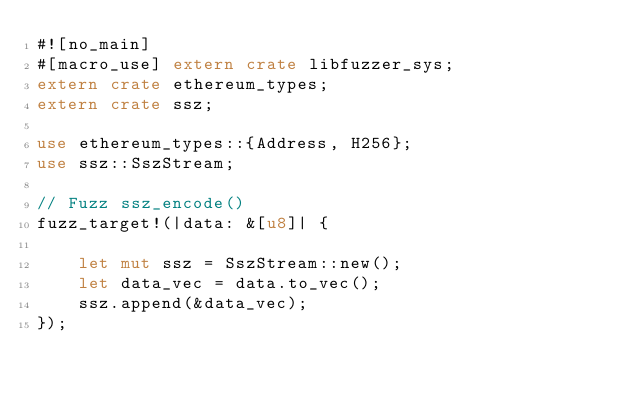<code> <loc_0><loc_0><loc_500><loc_500><_Rust_>#![no_main]
#[macro_use] extern crate libfuzzer_sys;
extern crate ethereum_types;
extern crate ssz;

use ethereum_types::{Address, H256};
use ssz::SszStream;

// Fuzz ssz_encode()
fuzz_target!(|data: &[u8]| {

    let mut ssz = SszStream::new();
    let data_vec = data.to_vec();
    ssz.append(&data_vec);
});
</code> 